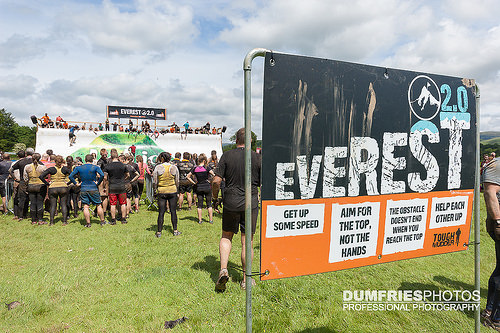<image>
Is there a grass behind the board? Yes. From this viewpoint, the grass is positioned behind the board, with the board partially or fully occluding the grass. 